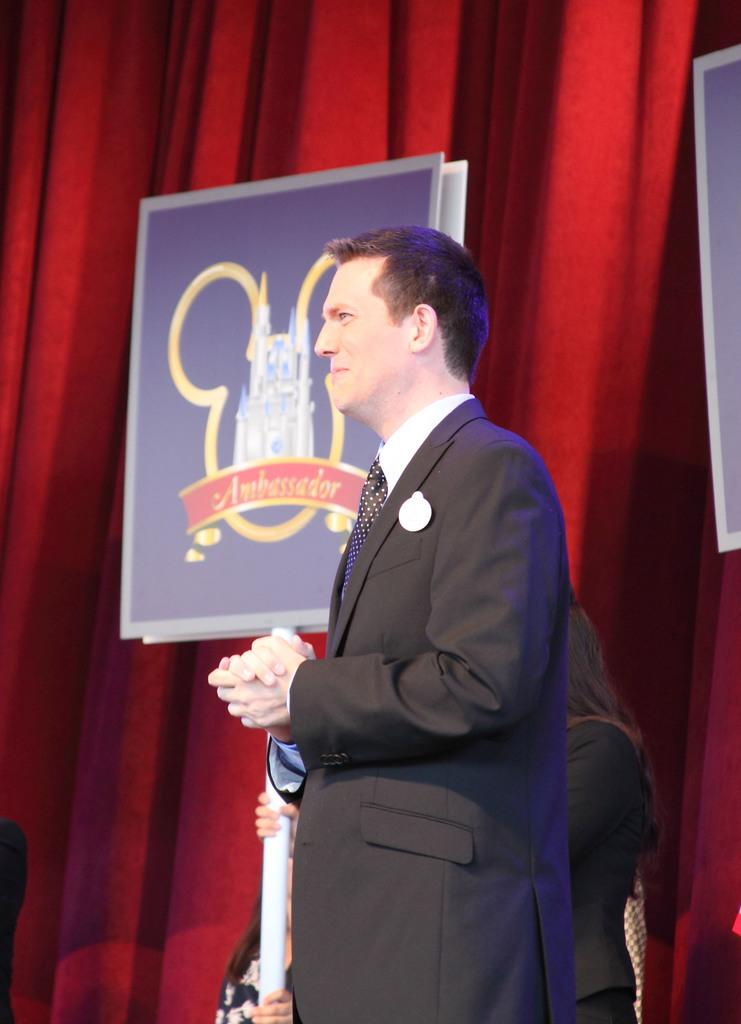How many people are visible in the image? There are people standing in the image, but the exact number cannot be determined from the provided facts. What is the person holding in the image? The person is holding a white object that looks like a paper. What can be seen in the background of the image? There is a poster attached to a curtain in the background of the image. What type of truck can be seen driving on the route in the image? There is no truck or route visible in the image; it only shows people, a person holding a white object, and a poster attached to a curtain. 